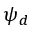<formula> <loc_0><loc_0><loc_500><loc_500>\psi _ { d }</formula> 